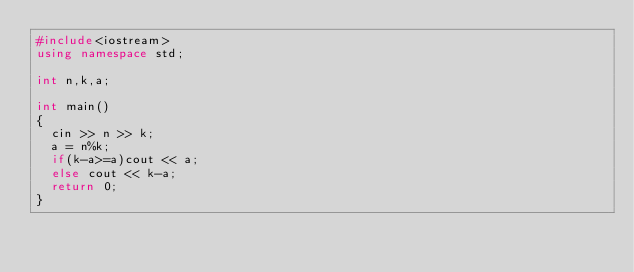Convert code to text. <code><loc_0><loc_0><loc_500><loc_500><_C++_>#include<iostream>
using namespace std;

int n,k,a;

int main()
{
	cin >> n >> k;
	a = n%k;
	if(k-a>=a)cout << a;
	else cout << k-a;
	return 0;
}</code> 